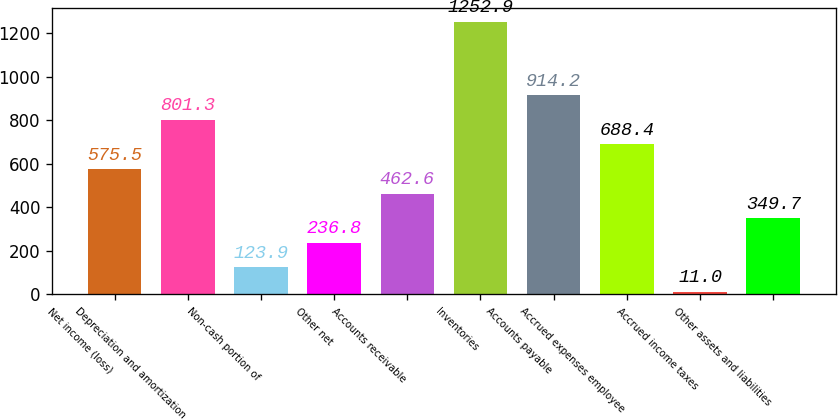<chart> <loc_0><loc_0><loc_500><loc_500><bar_chart><fcel>Net income (loss)<fcel>Depreciation and amortization<fcel>Non-cash portion of<fcel>Other net<fcel>Accounts receivable<fcel>Inventories<fcel>Accounts payable<fcel>Accrued expenses employee<fcel>Accrued income taxes<fcel>Other assets and liabilities<nl><fcel>575.5<fcel>801.3<fcel>123.9<fcel>236.8<fcel>462.6<fcel>1252.9<fcel>914.2<fcel>688.4<fcel>11<fcel>349.7<nl></chart> 